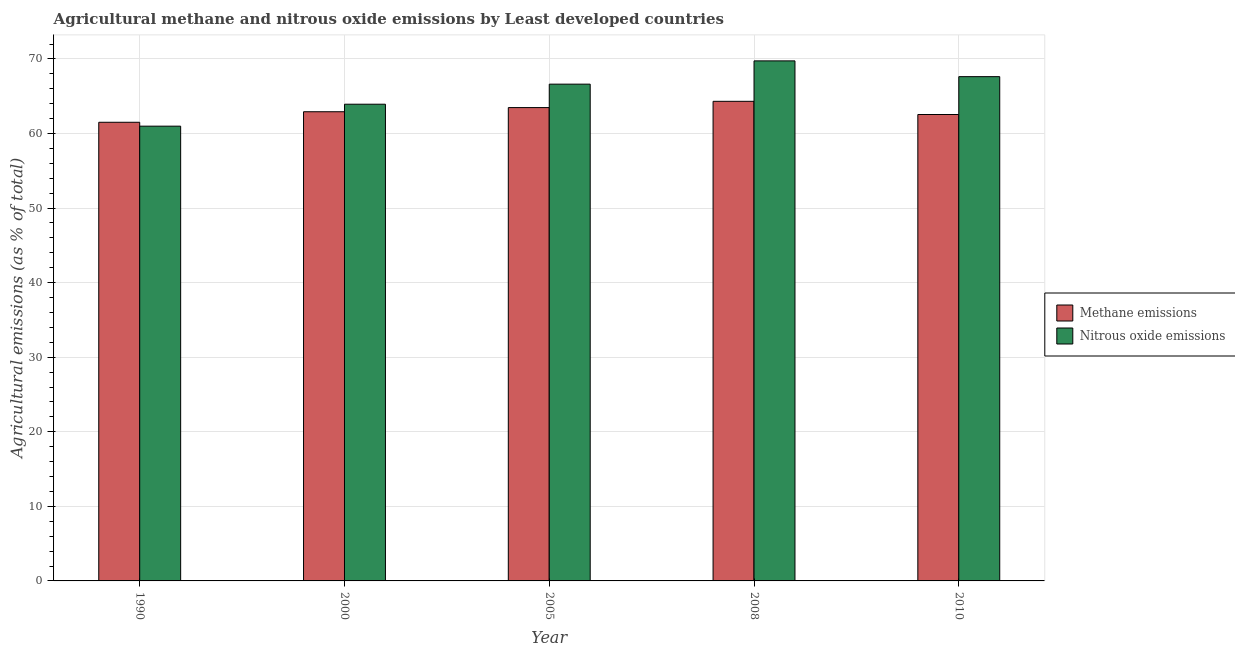How many different coloured bars are there?
Your answer should be very brief. 2. Are the number of bars per tick equal to the number of legend labels?
Your answer should be compact. Yes. Are the number of bars on each tick of the X-axis equal?
Give a very brief answer. Yes. How many bars are there on the 5th tick from the left?
Provide a succinct answer. 2. What is the label of the 4th group of bars from the left?
Your answer should be very brief. 2008. What is the amount of nitrous oxide emissions in 2000?
Your answer should be very brief. 63.93. Across all years, what is the maximum amount of methane emissions?
Provide a short and direct response. 64.32. Across all years, what is the minimum amount of nitrous oxide emissions?
Keep it short and to the point. 60.99. In which year was the amount of nitrous oxide emissions minimum?
Make the answer very short. 1990. What is the total amount of methane emissions in the graph?
Give a very brief answer. 314.77. What is the difference between the amount of nitrous oxide emissions in 2008 and that in 2010?
Give a very brief answer. 2.11. What is the difference between the amount of nitrous oxide emissions in 2005 and the amount of methane emissions in 2008?
Ensure brevity in your answer.  -3.12. What is the average amount of methane emissions per year?
Your response must be concise. 62.95. In the year 2008, what is the difference between the amount of nitrous oxide emissions and amount of methane emissions?
Provide a succinct answer. 0. What is the ratio of the amount of methane emissions in 1990 to that in 2008?
Keep it short and to the point. 0.96. Is the difference between the amount of nitrous oxide emissions in 1990 and 2000 greater than the difference between the amount of methane emissions in 1990 and 2000?
Provide a short and direct response. No. What is the difference between the highest and the second highest amount of nitrous oxide emissions?
Your answer should be very brief. 2.11. What is the difference between the highest and the lowest amount of methane emissions?
Offer a very short reply. 2.81. In how many years, is the amount of nitrous oxide emissions greater than the average amount of nitrous oxide emissions taken over all years?
Keep it short and to the point. 3. Is the sum of the amount of nitrous oxide emissions in 2000 and 2008 greater than the maximum amount of methane emissions across all years?
Give a very brief answer. Yes. What does the 2nd bar from the left in 2010 represents?
Provide a succinct answer. Nitrous oxide emissions. What does the 1st bar from the right in 2005 represents?
Ensure brevity in your answer.  Nitrous oxide emissions. What is the difference between two consecutive major ticks on the Y-axis?
Ensure brevity in your answer.  10. Does the graph contain any zero values?
Provide a succinct answer. No. Does the graph contain grids?
Your response must be concise. Yes. Where does the legend appear in the graph?
Make the answer very short. Center right. How many legend labels are there?
Provide a short and direct response. 2. What is the title of the graph?
Offer a terse response. Agricultural methane and nitrous oxide emissions by Least developed countries. Does "Current US$" appear as one of the legend labels in the graph?
Provide a succinct answer. No. What is the label or title of the X-axis?
Provide a short and direct response. Year. What is the label or title of the Y-axis?
Offer a terse response. Agricultural emissions (as % of total). What is the Agricultural emissions (as % of total) in Methane emissions in 1990?
Offer a terse response. 61.51. What is the Agricultural emissions (as % of total) of Nitrous oxide emissions in 1990?
Keep it short and to the point. 60.99. What is the Agricultural emissions (as % of total) of Methane emissions in 2000?
Your response must be concise. 62.92. What is the Agricultural emissions (as % of total) in Nitrous oxide emissions in 2000?
Ensure brevity in your answer.  63.93. What is the Agricultural emissions (as % of total) of Methane emissions in 2005?
Provide a succinct answer. 63.48. What is the Agricultural emissions (as % of total) in Nitrous oxide emissions in 2005?
Make the answer very short. 66.62. What is the Agricultural emissions (as % of total) in Methane emissions in 2008?
Provide a succinct answer. 64.32. What is the Agricultural emissions (as % of total) in Nitrous oxide emissions in 2008?
Provide a succinct answer. 69.74. What is the Agricultural emissions (as % of total) of Methane emissions in 2010?
Make the answer very short. 62.55. What is the Agricultural emissions (as % of total) of Nitrous oxide emissions in 2010?
Give a very brief answer. 67.63. Across all years, what is the maximum Agricultural emissions (as % of total) in Methane emissions?
Offer a very short reply. 64.32. Across all years, what is the maximum Agricultural emissions (as % of total) of Nitrous oxide emissions?
Make the answer very short. 69.74. Across all years, what is the minimum Agricultural emissions (as % of total) of Methane emissions?
Offer a very short reply. 61.51. Across all years, what is the minimum Agricultural emissions (as % of total) of Nitrous oxide emissions?
Your answer should be very brief. 60.99. What is the total Agricultural emissions (as % of total) in Methane emissions in the graph?
Provide a short and direct response. 314.77. What is the total Agricultural emissions (as % of total) in Nitrous oxide emissions in the graph?
Give a very brief answer. 328.9. What is the difference between the Agricultural emissions (as % of total) in Methane emissions in 1990 and that in 2000?
Offer a very short reply. -1.41. What is the difference between the Agricultural emissions (as % of total) of Nitrous oxide emissions in 1990 and that in 2000?
Provide a short and direct response. -2.94. What is the difference between the Agricultural emissions (as % of total) of Methane emissions in 1990 and that in 2005?
Keep it short and to the point. -1.97. What is the difference between the Agricultural emissions (as % of total) in Nitrous oxide emissions in 1990 and that in 2005?
Offer a very short reply. -5.63. What is the difference between the Agricultural emissions (as % of total) of Methane emissions in 1990 and that in 2008?
Ensure brevity in your answer.  -2.81. What is the difference between the Agricultural emissions (as % of total) in Nitrous oxide emissions in 1990 and that in 2008?
Keep it short and to the point. -8.76. What is the difference between the Agricultural emissions (as % of total) of Methane emissions in 1990 and that in 2010?
Your answer should be very brief. -1.04. What is the difference between the Agricultural emissions (as % of total) of Nitrous oxide emissions in 1990 and that in 2010?
Ensure brevity in your answer.  -6.64. What is the difference between the Agricultural emissions (as % of total) in Methane emissions in 2000 and that in 2005?
Provide a short and direct response. -0.56. What is the difference between the Agricultural emissions (as % of total) in Nitrous oxide emissions in 2000 and that in 2005?
Keep it short and to the point. -2.69. What is the difference between the Agricultural emissions (as % of total) of Methane emissions in 2000 and that in 2008?
Provide a succinct answer. -1.4. What is the difference between the Agricultural emissions (as % of total) of Nitrous oxide emissions in 2000 and that in 2008?
Provide a short and direct response. -5.81. What is the difference between the Agricultural emissions (as % of total) of Methane emissions in 2000 and that in 2010?
Your answer should be compact. 0.37. What is the difference between the Agricultural emissions (as % of total) of Nitrous oxide emissions in 2000 and that in 2010?
Make the answer very short. -3.7. What is the difference between the Agricultural emissions (as % of total) of Methane emissions in 2005 and that in 2008?
Provide a succinct answer. -0.84. What is the difference between the Agricultural emissions (as % of total) in Nitrous oxide emissions in 2005 and that in 2008?
Provide a succinct answer. -3.12. What is the difference between the Agricultural emissions (as % of total) in Methane emissions in 2005 and that in 2010?
Offer a terse response. 0.93. What is the difference between the Agricultural emissions (as % of total) in Nitrous oxide emissions in 2005 and that in 2010?
Offer a terse response. -1.01. What is the difference between the Agricultural emissions (as % of total) in Methane emissions in 2008 and that in 2010?
Offer a terse response. 1.77. What is the difference between the Agricultural emissions (as % of total) of Nitrous oxide emissions in 2008 and that in 2010?
Offer a terse response. 2.11. What is the difference between the Agricultural emissions (as % of total) in Methane emissions in 1990 and the Agricultural emissions (as % of total) in Nitrous oxide emissions in 2000?
Offer a very short reply. -2.42. What is the difference between the Agricultural emissions (as % of total) of Methane emissions in 1990 and the Agricultural emissions (as % of total) of Nitrous oxide emissions in 2005?
Your response must be concise. -5.11. What is the difference between the Agricultural emissions (as % of total) in Methane emissions in 1990 and the Agricultural emissions (as % of total) in Nitrous oxide emissions in 2008?
Ensure brevity in your answer.  -8.23. What is the difference between the Agricultural emissions (as % of total) in Methane emissions in 1990 and the Agricultural emissions (as % of total) in Nitrous oxide emissions in 2010?
Provide a succinct answer. -6.12. What is the difference between the Agricultural emissions (as % of total) in Methane emissions in 2000 and the Agricultural emissions (as % of total) in Nitrous oxide emissions in 2005?
Make the answer very short. -3.7. What is the difference between the Agricultural emissions (as % of total) in Methane emissions in 2000 and the Agricultural emissions (as % of total) in Nitrous oxide emissions in 2008?
Keep it short and to the point. -6.82. What is the difference between the Agricultural emissions (as % of total) in Methane emissions in 2000 and the Agricultural emissions (as % of total) in Nitrous oxide emissions in 2010?
Provide a short and direct response. -4.71. What is the difference between the Agricultural emissions (as % of total) in Methane emissions in 2005 and the Agricultural emissions (as % of total) in Nitrous oxide emissions in 2008?
Make the answer very short. -6.26. What is the difference between the Agricultural emissions (as % of total) of Methane emissions in 2005 and the Agricultural emissions (as % of total) of Nitrous oxide emissions in 2010?
Provide a succinct answer. -4.15. What is the difference between the Agricultural emissions (as % of total) in Methane emissions in 2008 and the Agricultural emissions (as % of total) in Nitrous oxide emissions in 2010?
Your response must be concise. -3.31. What is the average Agricultural emissions (as % of total) in Methane emissions per year?
Offer a very short reply. 62.95. What is the average Agricultural emissions (as % of total) of Nitrous oxide emissions per year?
Provide a succinct answer. 65.78. In the year 1990, what is the difference between the Agricultural emissions (as % of total) of Methane emissions and Agricultural emissions (as % of total) of Nitrous oxide emissions?
Your answer should be very brief. 0.52. In the year 2000, what is the difference between the Agricultural emissions (as % of total) in Methane emissions and Agricultural emissions (as % of total) in Nitrous oxide emissions?
Your response must be concise. -1.01. In the year 2005, what is the difference between the Agricultural emissions (as % of total) of Methane emissions and Agricultural emissions (as % of total) of Nitrous oxide emissions?
Keep it short and to the point. -3.14. In the year 2008, what is the difference between the Agricultural emissions (as % of total) in Methane emissions and Agricultural emissions (as % of total) in Nitrous oxide emissions?
Your answer should be very brief. -5.42. In the year 2010, what is the difference between the Agricultural emissions (as % of total) of Methane emissions and Agricultural emissions (as % of total) of Nitrous oxide emissions?
Provide a succinct answer. -5.08. What is the ratio of the Agricultural emissions (as % of total) in Methane emissions in 1990 to that in 2000?
Make the answer very short. 0.98. What is the ratio of the Agricultural emissions (as % of total) of Nitrous oxide emissions in 1990 to that in 2000?
Give a very brief answer. 0.95. What is the ratio of the Agricultural emissions (as % of total) of Methane emissions in 1990 to that in 2005?
Provide a short and direct response. 0.97. What is the ratio of the Agricultural emissions (as % of total) of Nitrous oxide emissions in 1990 to that in 2005?
Provide a short and direct response. 0.92. What is the ratio of the Agricultural emissions (as % of total) in Methane emissions in 1990 to that in 2008?
Provide a succinct answer. 0.96. What is the ratio of the Agricultural emissions (as % of total) of Nitrous oxide emissions in 1990 to that in 2008?
Keep it short and to the point. 0.87. What is the ratio of the Agricultural emissions (as % of total) in Methane emissions in 1990 to that in 2010?
Keep it short and to the point. 0.98. What is the ratio of the Agricultural emissions (as % of total) in Nitrous oxide emissions in 1990 to that in 2010?
Provide a short and direct response. 0.9. What is the ratio of the Agricultural emissions (as % of total) in Nitrous oxide emissions in 2000 to that in 2005?
Keep it short and to the point. 0.96. What is the ratio of the Agricultural emissions (as % of total) in Methane emissions in 2000 to that in 2008?
Make the answer very short. 0.98. What is the ratio of the Agricultural emissions (as % of total) of Nitrous oxide emissions in 2000 to that in 2008?
Provide a short and direct response. 0.92. What is the ratio of the Agricultural emissions (as % of total) in Methane emissions in 2000 to that in 2010?
Provide a short and direct response. 1.01. What is the ratio of the Agricultural emissions (as % of total) in Nitrous oxide emissions in 2000 to that in 2010?
Keep it short and to the point. 0.95. What is the ratio of the Agricultural emissions (as % of total) of Methane emissions in 2005 to that in 2008?
Give a very brief answer. 0.99. What is the ratio of the Agricultural emissions (as % of total) in Nitrous oxide emissions in 2005 to that in 2008?
Your response must be concise. 0.96. What is the ratio of the Agricultural emissions (as % of total) of Methane emissions in 2005 to that in 2010?
Ensure brevity in your answer.  1.01. What is the ratio of the Agricultural emissions (as % of total) in Nitrous oxide emissions in 2005 to that in 2010?
Your answer should be very brief. 0.99. What is the ratio of the Agricultural emissions (as % of total) in Methane emissions in 2008 to that in 2010?
Provide a succinct answer. 1.03. What is the ratio of the Agricultural emissions (as % of total) of Nitrous oxide emissions in 2008 to that in 2010?
Your answer should be very brief. 1.03. What is the difference between the highest and the second highest Agricultural emissions (as % of total) in Methane emissions?
Your answer should be very brief. 0.84. What is the difference between the highest and the second highest Agricultural emissions (as % of total) in Nitrous oxide emissions?
Your response must be concise. 2.11. What is the difference between the highest and the lowest Agricultural emissions (as % of total) in Methane emissions?
Keep it short and to the point. 2.81. What is the difference between the highest and the lowest Agricultural emissions (as % of total) of Nitrous oxide emissions?
Give a very brief answer. 8.76. 